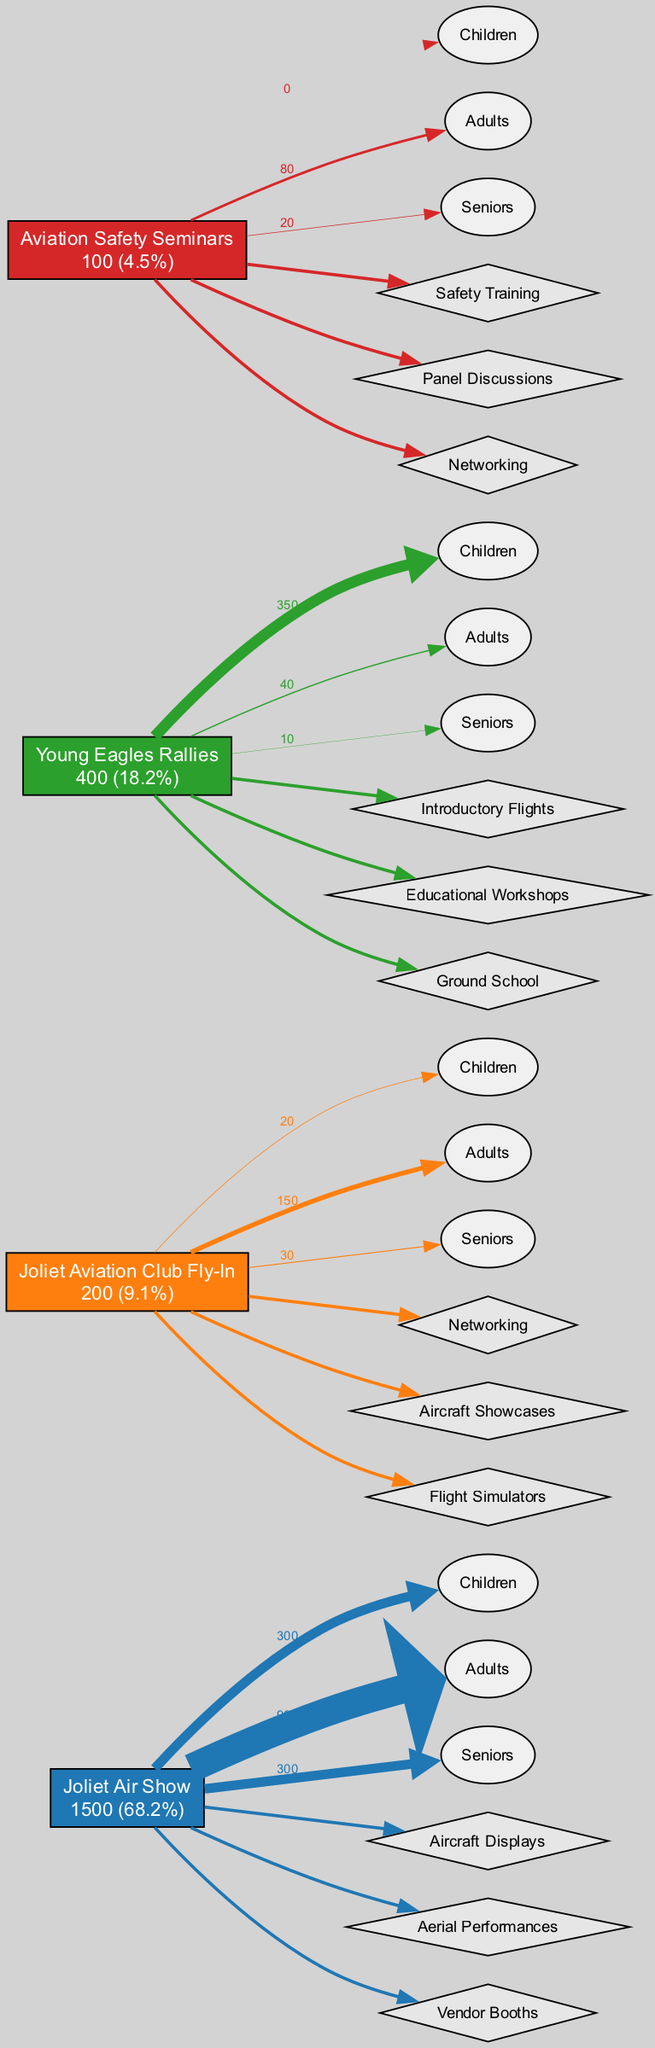What is the total attendance across all events? To find the total attendance, we sum the attendance values for each event: 1500 (Joliet Air Show) + 200 (Joliet Aviation Club Fly-In) + 400 (Young Eagles Rallies) + 100 (Aviation Safety Seminars) = 2200.
Answer: 2200 Which event had the highest attendance? By comparing the attendance numbers, the Joliet Air Show has the highest attendance at 1500, significantly more than the other events.
Answer: Joliet Air Show How many activities are offered at the Joliet Aviation Club Fly-In? The Joliet Aviation Club Fly-In lists three activities: Networking, Aircraft Showcases, and Flight Simulators. Therefore, the total number of activities offered is three.
Answer: 3 What percentage of attendees at the Young Eagles Rallies are children? The Young Eagles Rallies had 400 attendees, out of which 350 are children. To find the percentage, we calculate (350/400) * 100 = 87.5%.
Answer: 87.5% What is the ratio of male to female attendees at Aviation Safety Seminars? At the Aviation Safety Seminars, there are 70 male and 30 female attendees. The ratio can be simplified as 7:3.
Answer: 7:3 Which demographic group was the largest at the Joliet Air Show? At the Joliet Air Show, the largest demographic group is adults, with 900 attendees, compared to 300 children and 300 seniors.
Answer: Adults How many edges connect to the Young Eagles Rallies event? The Young Eagles Rallies event has connections (edges) for its age demographics (children, adults, seniors) as well as connections for its activities (Introductory Flights, Educational Workshops, Ground School), totaling six edges.
Answer: 6 What type of activities are offered at Aviation Safety Seminars? The Aviation Safety Seminars offer three types of activities: Safety Training, Panel Discussions, and Networking.
Answer: Safety Training, Panel Discussions, Networking What demographic group contributed the least to the attendance at the Joliet Aviation Club Fly-In? At the Joliet Aviation Club Fly-In, children's attendance is the least at 20, while adults and seniors have higher numbers at 150 and 30, respectively.
Answer: Children 